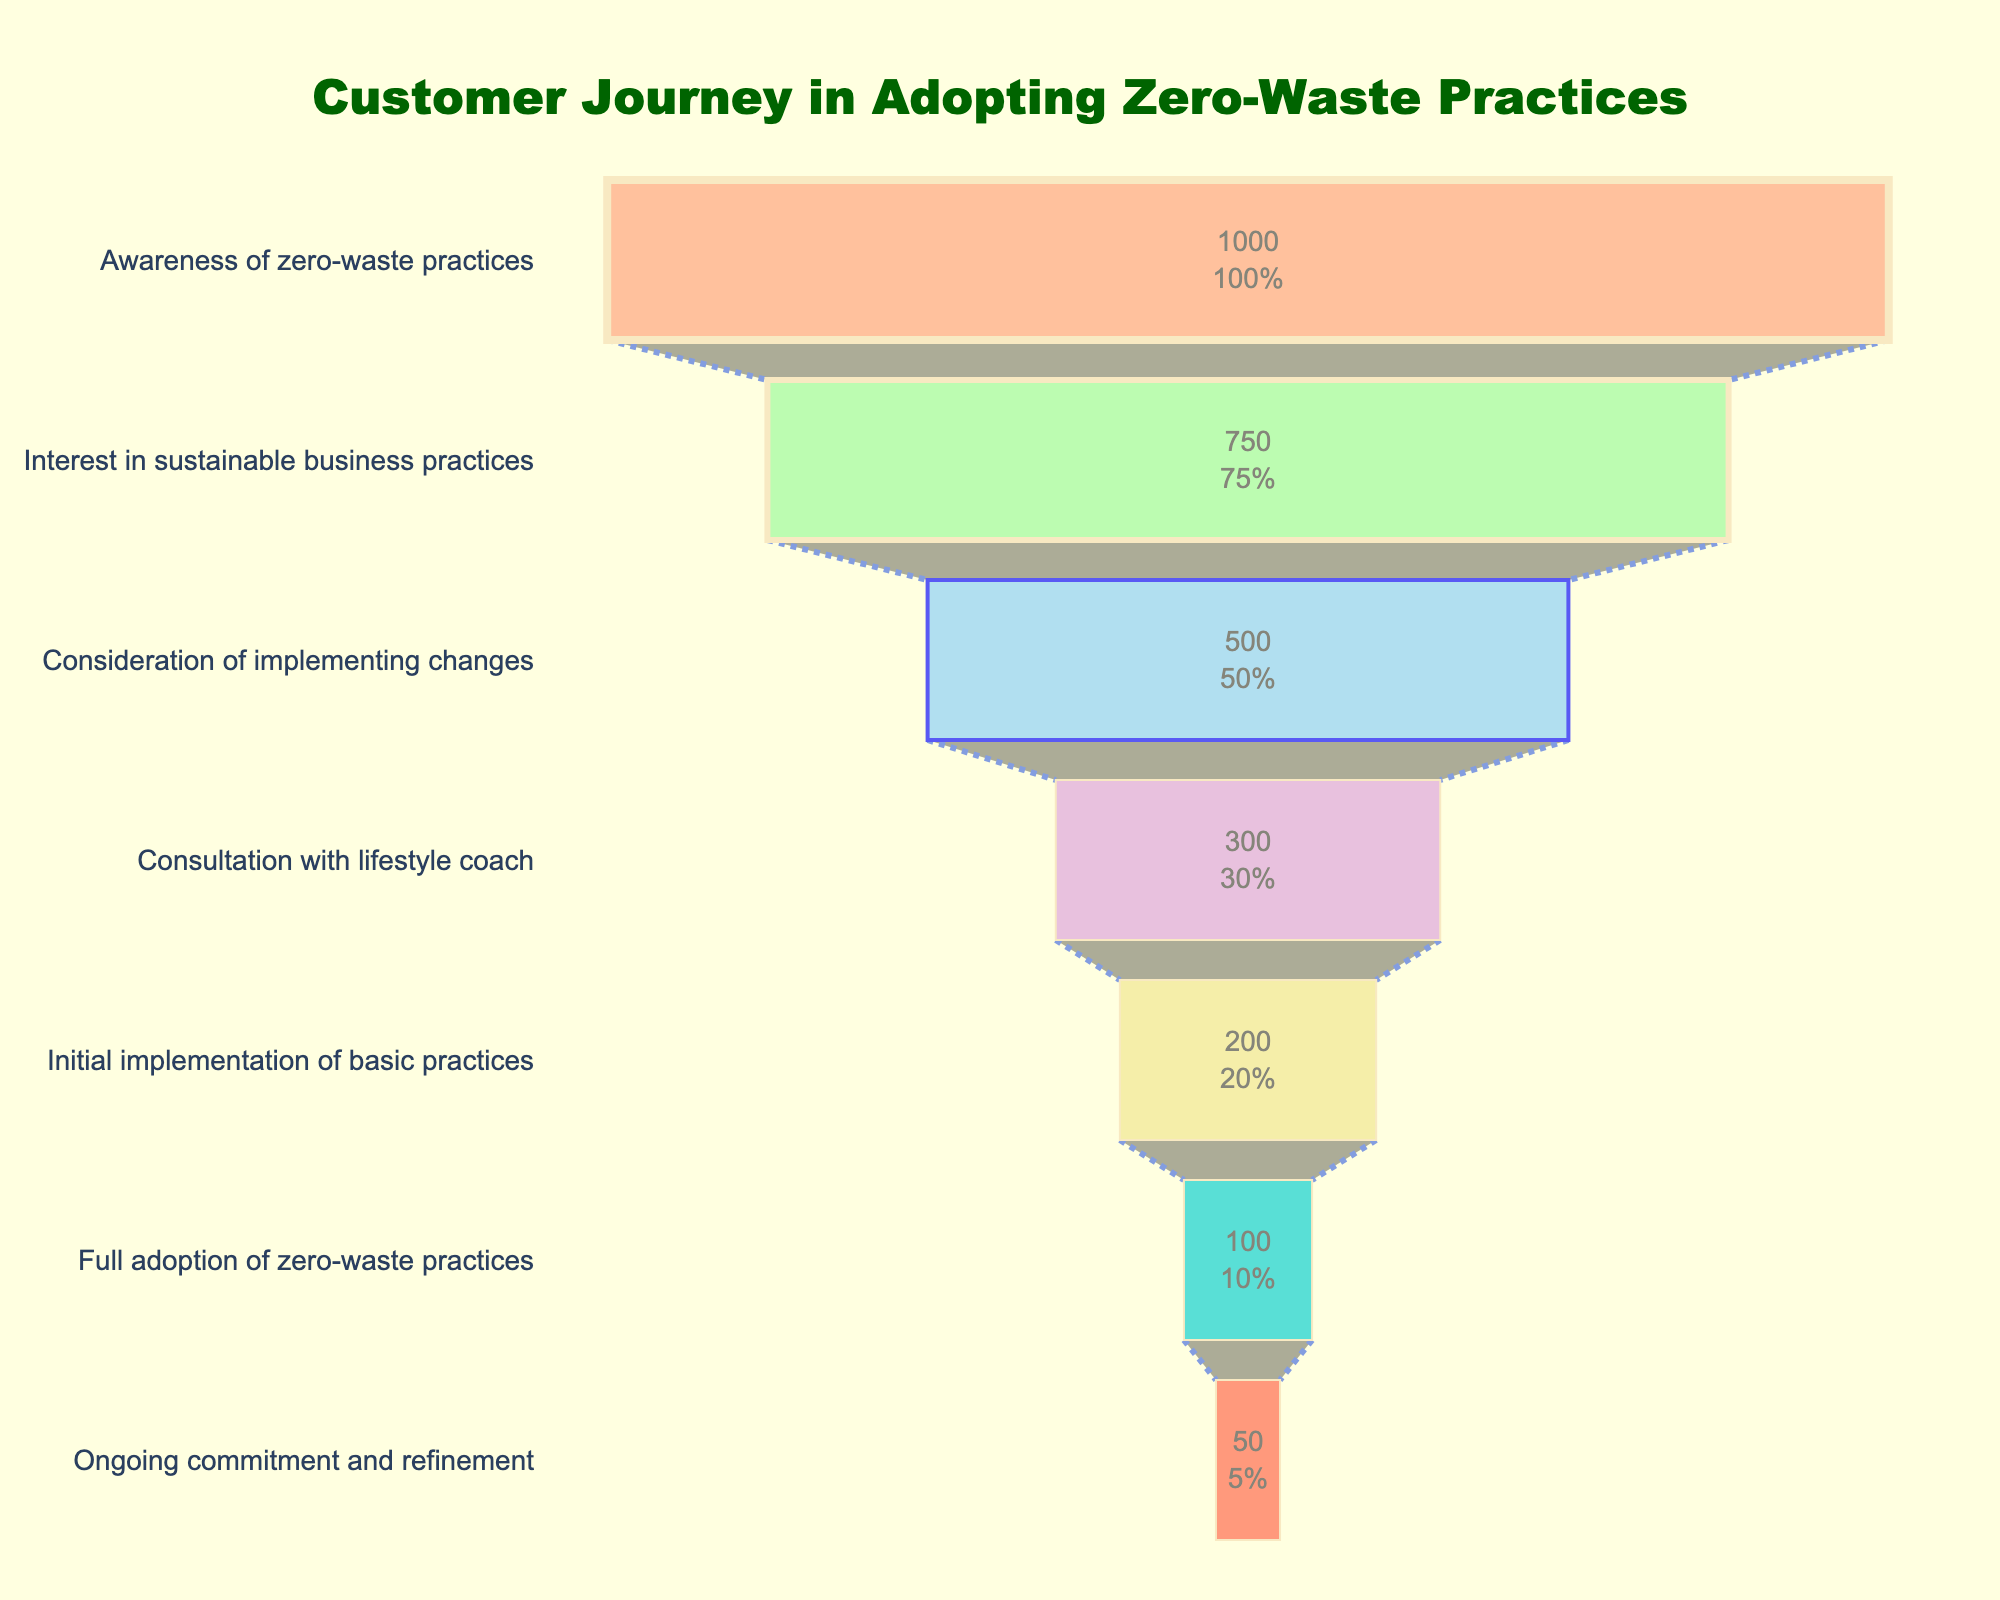What's the title of the chart? The chart's title is written at the top center of the figure. It states what the figure is about. It reads "Customer Journey in Adopting Zero-Waste Practices."
Answer: Customer Journey in Adopting Zero-Waste Practices What is the number of customers who became interested in sustainable business practices? Look at the second stage of the funnel labeled "Interest in sustainable business practices." The number associated with it is 750 customers.
Answer: 750 How many customers are still committed to zero-waste practices? At the bottom of the funnel, the final stage is labeled "Ongoing commitment and refinement," which shows the remaining number of customers.
Answer: 50 How many stages are there in the customer journey for adopting zero-waste practices? Count each unique labeled stage on the y-axis of the funnel chart where customers' progress is tracked.
Answer: 7 Which stage has the largest drop in customer numbers? Compare the number of customers between each consecutive stage. The largest drop can be observed by calculating the difference between each stage.
Answer: From 'Awareness of zero-waste practices' to 'Interest in sustainable business practices' What percentage of customers consulted with a lifestyle coach relative to those who were aware of zero-waste practices? Percentage is calculated using the number of customers who consulted with a lifestyle coach (300) relative to those aware of zero-waste practices (1000). The calculation is (300 / 1000) * 100%.
Answer: 30% By what percentage did the customers reduce from the 'Consideration of implementing changes' to 'Consultation with lifestyle coach'? Calculate the percentage reduction using the formula (Initial - Final) / Initial * 100%. For the given stages, it's (500 - 300) / 500 * 100%.
Answer: 40% At which stage does the customer count drop below half of those initially aware? Identify the stage where the customer count drops below 500, which is half of the initial 1000 customers. The stage is 'Consultation with lifestyle coach' (300 customers).
Answer: Consultation with lifestyle coach What proportion of customers fully adopted zero-waste practices out of those who initially considered implementing changes? Calculate the proportion using the number of customers who fully adopted zero-waste practices (100) divided by those who considered implementing changes (500). The result is 100 / 500.
Answer: 0.20 How many more customers were interested in sustainable business practices than those who fully adopted zero-waste practices? Subtract the number of customers who fully adopted zero-waste practices (100) from the number of customers interested in sustainable business practices (750).
Answer: 650 